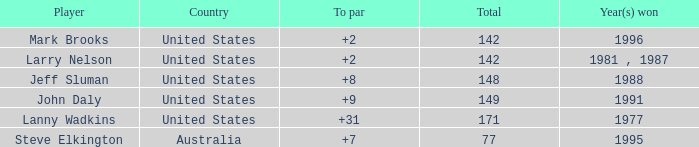Name the Total of jeff sluman? 148.0. 